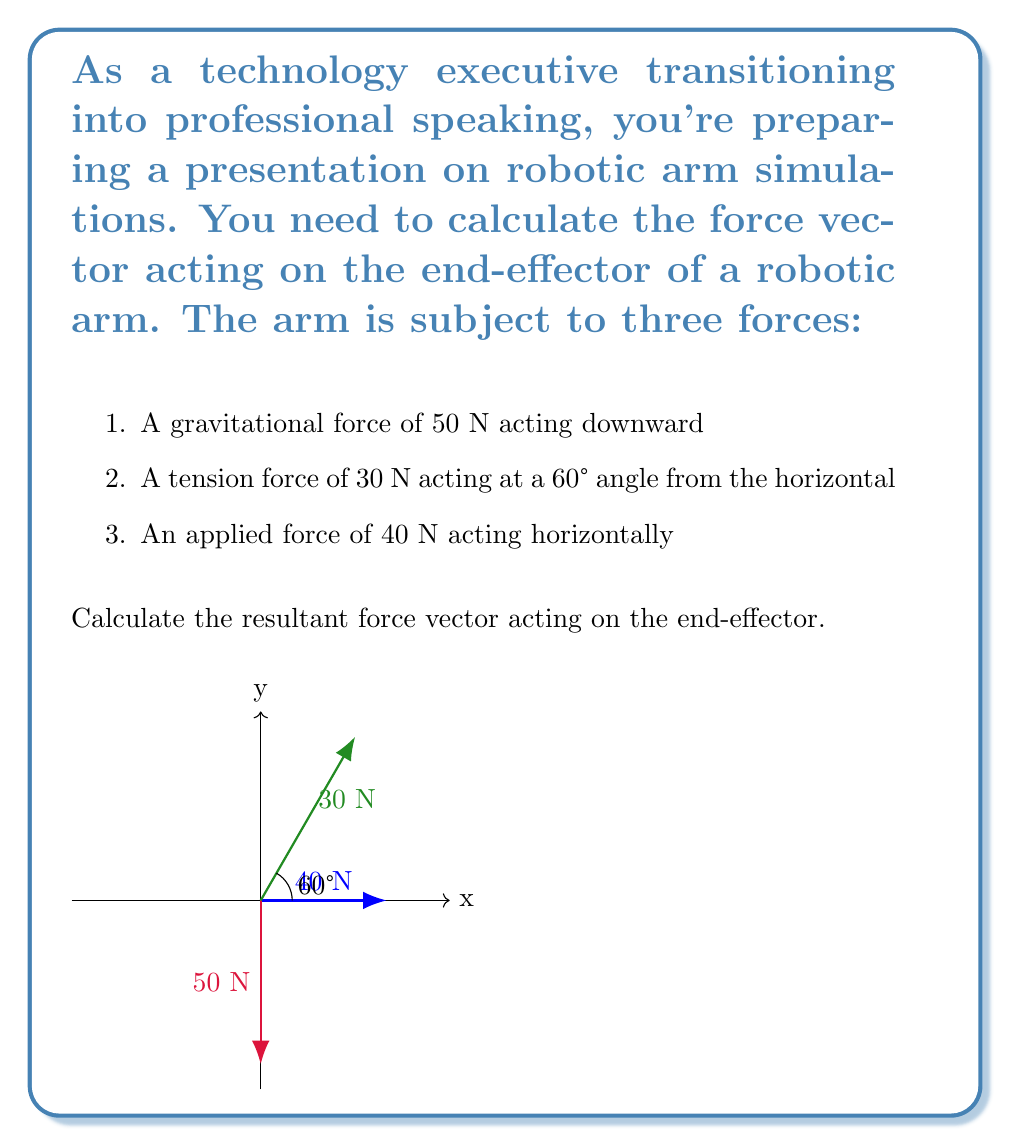Can you solve this math problem? Let's approach this step-by-step:

1) First, we need to break down each force into its x and y components.

2) For the gravitational force:
   $F_{g_x} = 0$ (no horizontal component)
   $F_{g_y} = -50$ N (negative because it's downward)

3) For the tension force:
   $F_{t_x} = 30 \cos(60°) = 30 \cdot 0.5 = 15$ N
   $F_{t_y} = 30 \sin(60°) = 30 \cdot \frac{\sqrt{3}}{2} \approx 25.98$ N

4) For the applied horizontal force:
   $F_{a_x} = 40$ N
   $F_{a_y} = 0$ (no vertical component)

5) Now, we sum up all x components and all y components:
   $F_x = F_{g_x} + F_{t_x} + F_{a_x} = 0 + 15 + 40 = 55$ N
   $F_y = F_{g_y} + F_{t_y} + F_{a_y} = -50 + 25.98 + 0 \approx -24.02$ N

6) The resultant force vector is therefore:
   $\vec{F} = (55, -24.02)$ N

7) To find the magnitude of this vector:
   $|\vec{F}| = \sqrt{55^2 + (-24.02)^2} \approx 60.01$ N

8) To find the angle with respect to the horizontal:
   $\theta = \tan^{-1}(\frac{-24.02}{55}) \approx -23.58°$

Therefore, the resultant force vector has a magnitude of approximately 60.01 N and acts at an angle of -23.58° from the horizontal (below the positive x-axis).
Answer: $\vec{F} = (55, -24.02)$ N, or 60.01 N at -23.58° from horizontal 